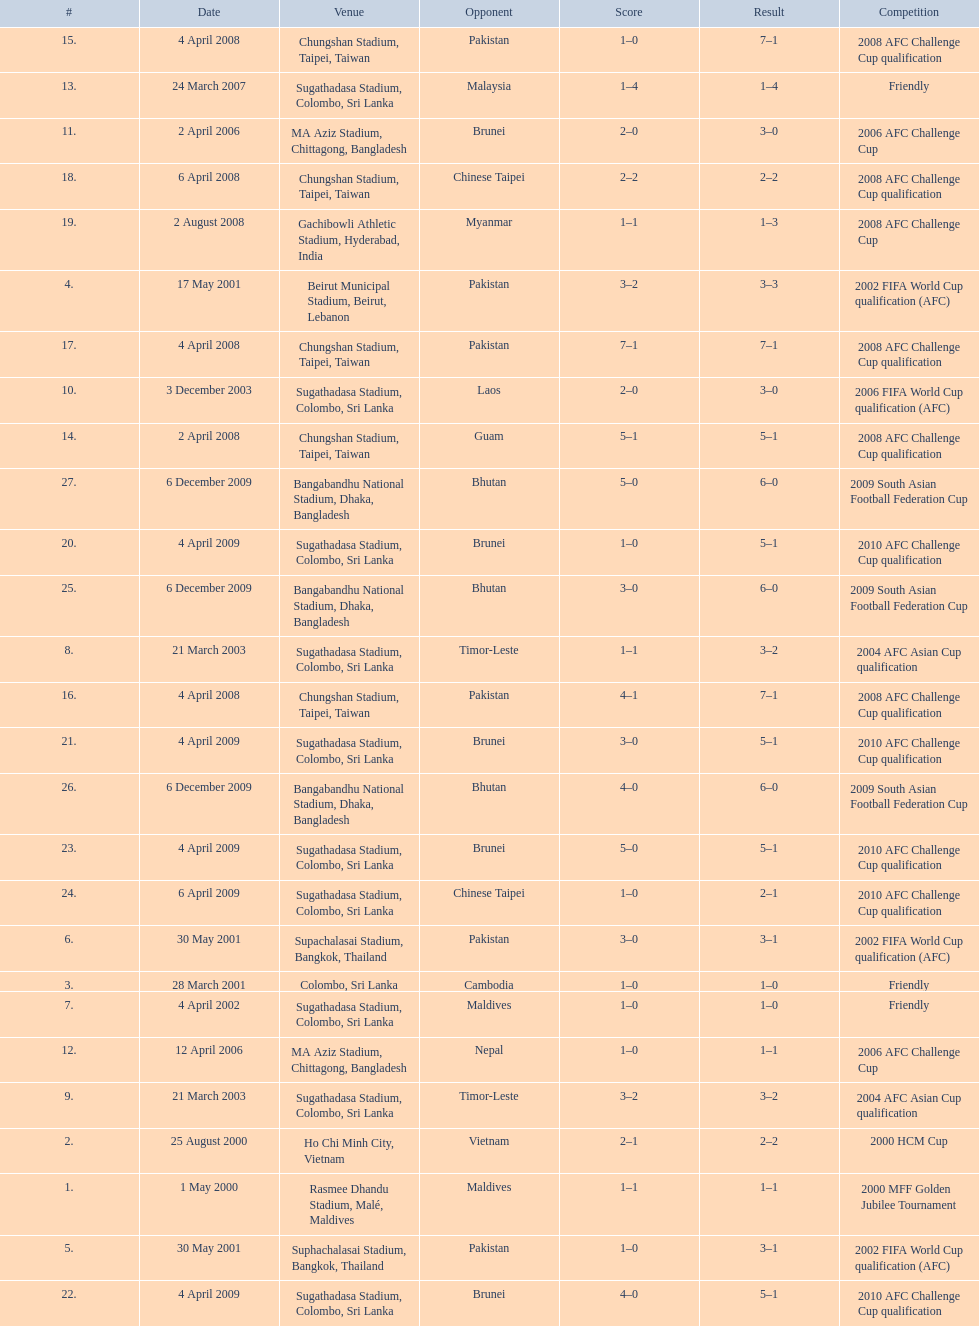Which venue has the largest result Chungshan Stadium, Taipei, Taiwan. 